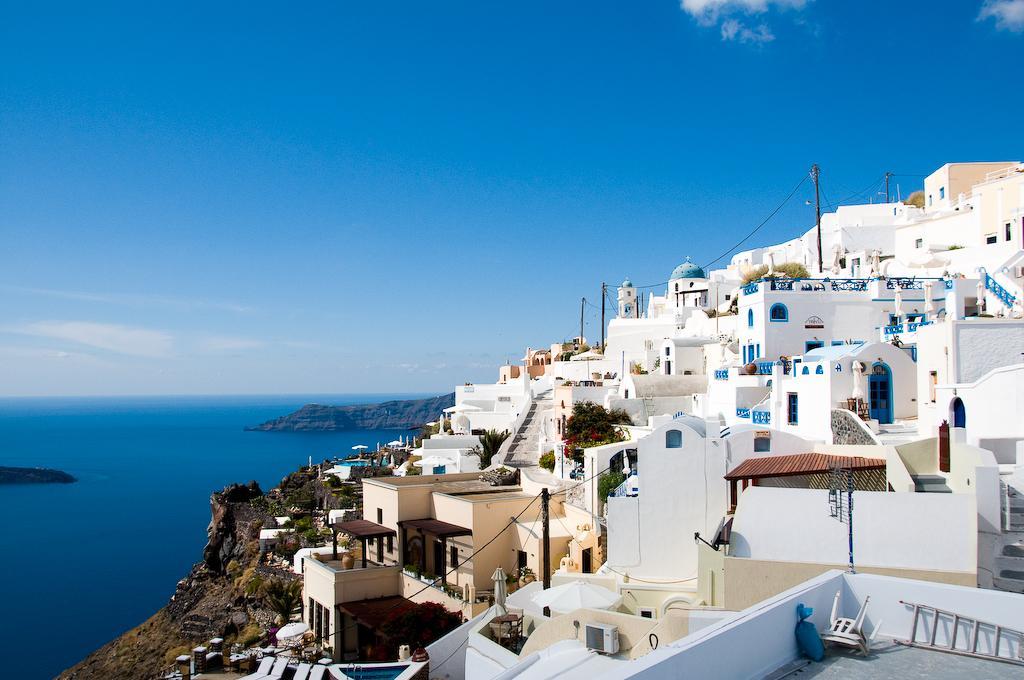How would you summarize this image in a sentence or two? In this picture we can see chairs, ladder, buildings, trees, poles, water and in the background we can see the sky with clouds. 